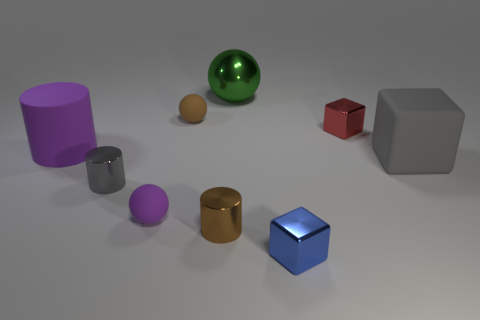Add 1 green objects. How many objects exist? 10 Subtract all large spheres. How many spheres are left? 2 Subtract all blue blocks. How many blocks are left? 2 Subtract 1 balls. How many balls are left? 2 Subtract all cubes. How many objects are left? 6 Subtract all red blocks. Subtract all purple balls. How many blocks are left? 2 Subtract all big green rubber spheres. Subtract all red metallic objects. How many objects are left? 8 Add 6 large cylinders. How many large cylinders are left? 7 Add 8 small blue shiny cubes. How many small blue shiny cubes exist? 9 Subtract 0 green cylinders. How many objects are left? 9 